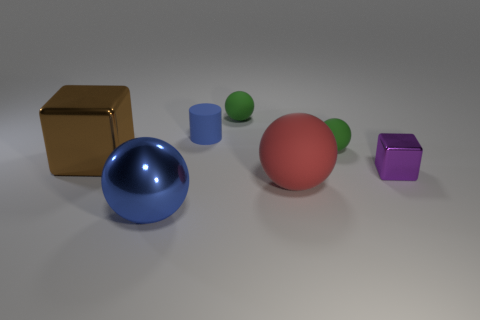Subtract all purple cubes. How many green balls are left? 2 Subtract all red spheres. How many spheres are left? 3 Subtract all shiny spheres. How many spheres are left? 3 Subtract 1 spheres. How many spheres are left? 3 Add 2 metal cubes. How many objects exist? 9 Subtract all blocks. How many objects are left? 5 Subtract all green blocks. Subtract all green cylinders. How many blocks are left? 2 Subtract all large rubber things. Subtract all red balls. How many objects are left? 5 Add 5 big things. How many big things are left? 8 Add 4 large blue spheres. How many large blue spheres exist? 5 